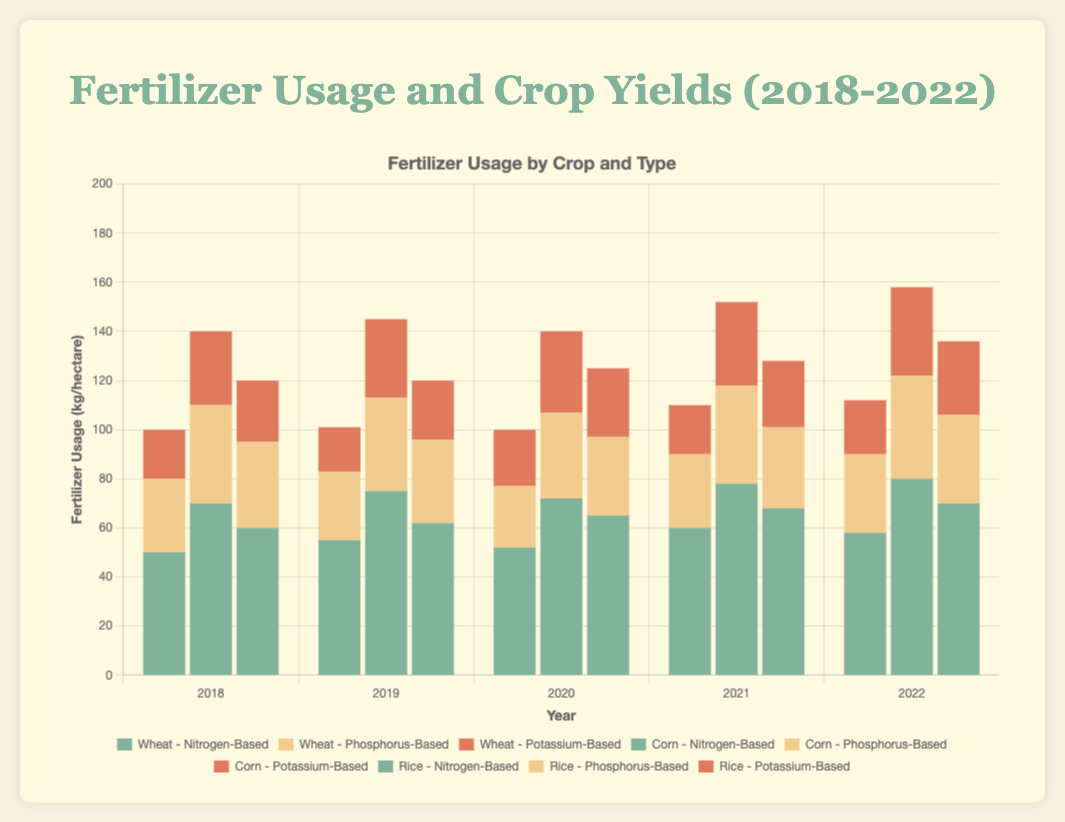What is the total amount of Nitrogen-based fertilizers used for Wheat over the 5 years? Sum the Nitrogen-based fertilizer usage for Wheat in each year from 2018 to 2022: 50 + 55 + 52 + 60 + 58 = 275 kg/hectare
Answer: 275 kg/hectare How did the yield of Corn change from 2018 to 2022? Subtract the yield in 2018 from the yield in 2022: 11.0 - 10.0 = 1.0 tons/hectare increase
Answer: 1.0 tons/hectare increase Which crop had the highest yield in 2021 and what was it? Identify the yields for all crops in 2021 and compare them: Wheat (9.2), Corn (10.8), Rice (8.3). Corn had the highest yield
Answer: Corn, 10.8 tons/hectare In 2019, which fertilizer type was used more for Corn, Nitrogen-based or Phosphorus-based? Compare the amounts of Nitrogen-based (75) and Phosphorus-based (38) fertilizers used for Corn in 2019. Nitrogen-based usage was higher
Answer: Nitrogen-based What is the average yield for Rice from 2018 to 2022? Sum the yields for Rice over the 5 years and divide by 5: (7.5 + 7.8 + 8.0 + 8.3 + 8.5)/5 = 8.02 tons/hectare
Answer: 8.02 tons/hectare What is the total fertilizer usage for Corn in 2020? Sum the Nitrogen-based, Phosphorus-based, and Potassium-based fertilizers for Corn in 2020: 72 + 35 + 33 = 140 kg/hectare
Answer: 140 kg/hectare Did the fertilizer usage for Wheat increase, decrease, or stay the same from 2021 to 2022? Compare the total fertilizer usage for Wheat in 2021 (60+30+20=110) and 2022 (58+32+22=112). The usage increased by 2 kg/hectare
Answer: Increase Which year had the highest yield for Rice? Compare the yields for Rice across all years: 2018 (7.5), 2019 (7.8), 2020 (8.0), 2021 (8.3), 2022 (8.5). The highest yield was in 2022
Answer: 2022 In which crop and year was the highest single usage of Nitrogen-based fertilizers? Identify the years and crops with their Nitrogen-based usage: Wheat (2021: 60), Corn (2022: 80), Rice (2022: 70). The highest was for Corn in 2022 with 80 kg/hectare
Answer: Corn, 2022 